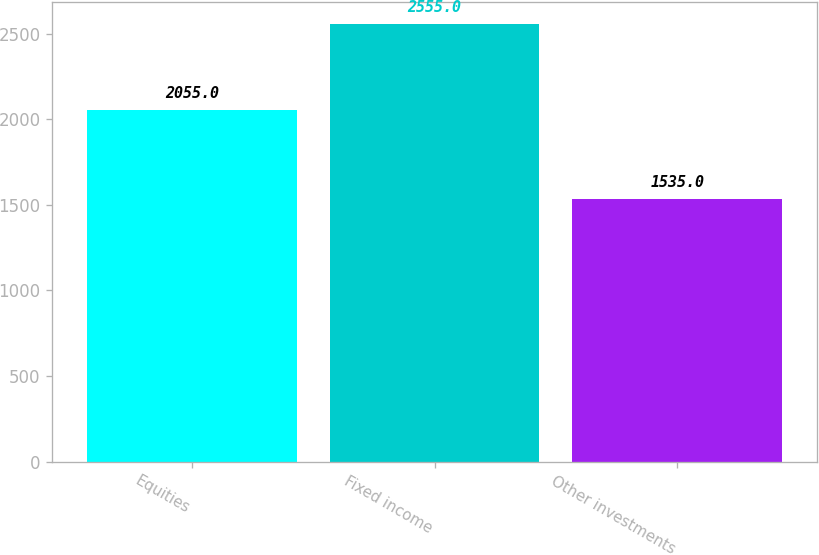Convert chart. <chart><loc_0><loc_0><loc_500><loc_500><bar_chart><fcel>Equities<fcel>Fixed income<fcel>Other investments<nl><fcel>2055<fcel>2555<fcel>1535<nl></chart> 